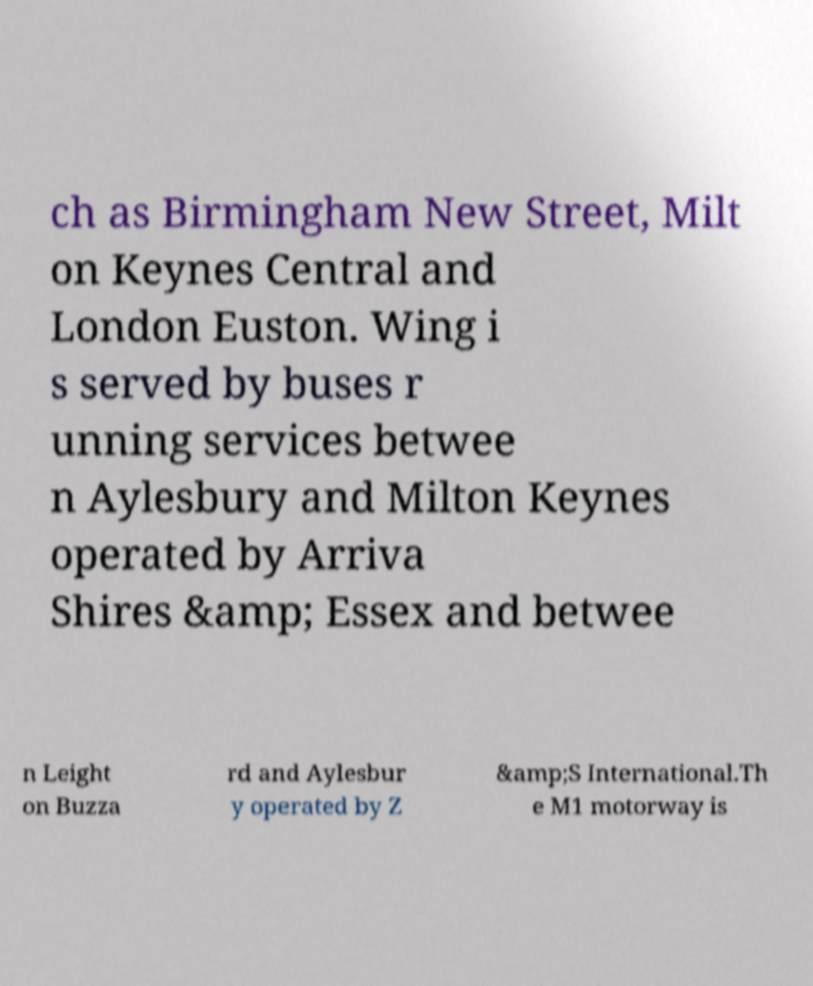Please read and relay the text visible in this image. What does it say? ch as Birmingham New Street, Milt on Keynes Central and London Euston. Wing i s served by buses r unning services betwee n Aylesbury and Milton Keynes operated by Arriva Shires &amp; Essex and betwee n Leight on Buzza rd and Aylesbur y operated by Z &amp;S International.Th e M1 motorway is 